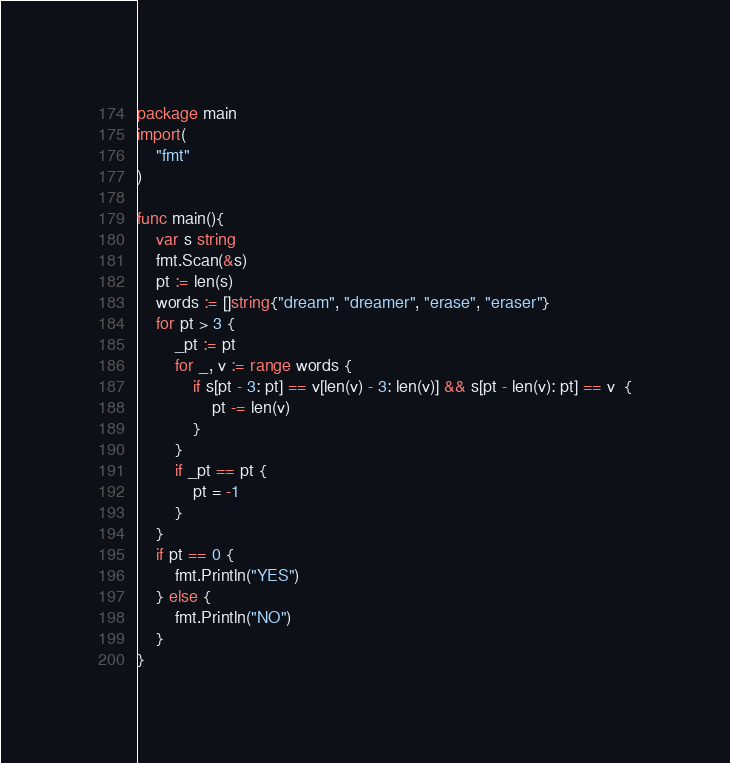Convert code to text. <code><loc_0><loc_0><loc_500><loc_500><_Go_>package main
import(
    "fmt"
)

func main(){
    var s string
    fmt.Scan(&s)
    pt := len(s)
    words := []string{"dream", "dreamer", "erase", "eraser"}
    for pt > 3 {
        _pt := pt
        for _, v := range words {
            if s[pt - 3: pt] == v[len(v) - 3: len(v)] && s[pt - len(v): pt] == v  {
                pt -= len(v)
            }
        }
        if _pt == pt {
            pt = -1
        }
    }
    if pt == 0 {
        fmt.Println("YES")
    } else {
        fmt.Println("NO")
    }
}</code> 